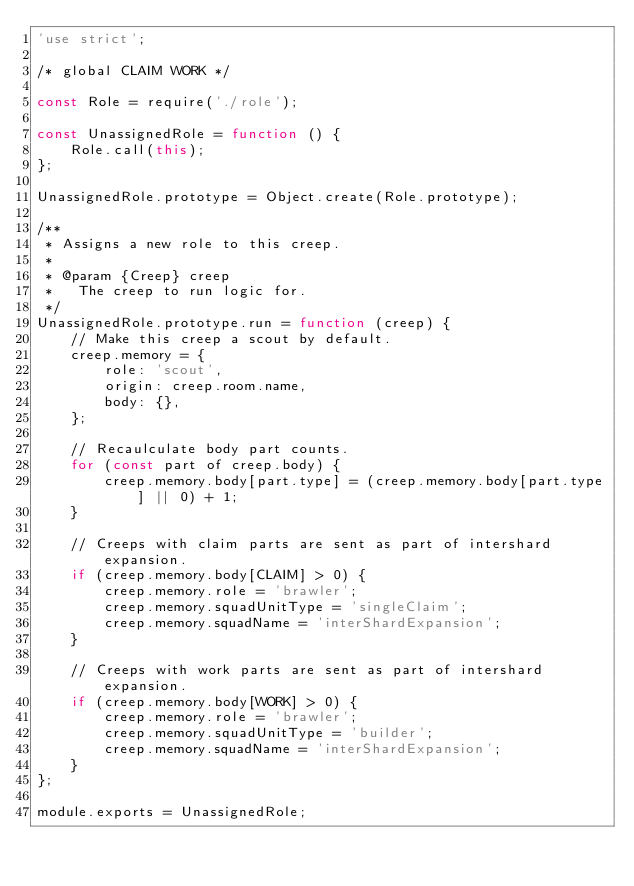<code> <loc_0><loc_0><loc_500><loc_500><_JavaScript_>'use strict';

/* global CLAIM WORK */

const Role = require('./role');

const UnassignedRole = function () {
	Role.call(this);
};

UnassignedRole.prototype = Object.create(Role.prototype);

/**
 * Assigns a new role to this creep.
 *
 * @param {Creep} creep
 *   The creep to run logic for.
 */
UnassignedRole.prototype.run = function (creep) {
	// Make this creep a scout by default.
	creep.memory = {
		role: 'scout',
		origin: creep.room.name,
		body: {},
	};

	// Recaulculate body part counts.
	for (const part of creep.body) {
		creep.memory.body[part.type] = (creep.memory.body[part.type] || 0) + 1;
	}

	// Creeps with claim parts are sent as part of intershard expansion.
	if (creep.memory.body[CLAIM] > 0) {
		creep.memory.role = 'brawler';
		creep.memory.squadUnitType = 'singleClaim';
		creep.memory.squadName = 'interShardExpansion';
	}

	// Creeps with work parts are sent as part of intershard expansion.
	if (creep.memory.body[WORK] > 0) {
		creep.memory.role = 'brawler';
		creep.memory.squadUnitType = 'builder';
		creep.memory.squadName = 'interShardExpansion';
	}
};

module.exports = UnassignedRole;
</code> 